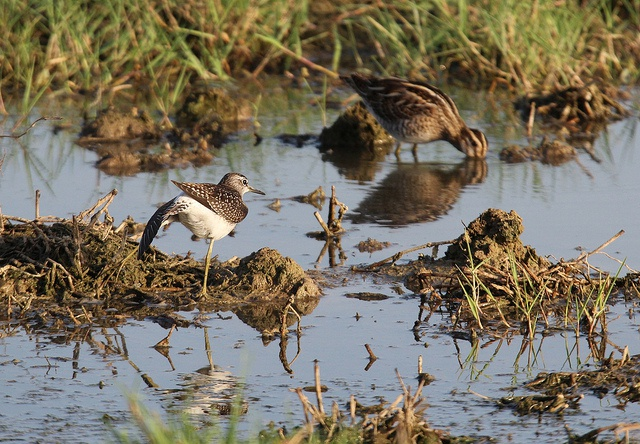Describe the objects in this image and their specific colors. I can see bird in darkgreen, black, maroon, and gray tones and bird in darkgreen, black, beige, maroon, and darkgray tones in this image. 